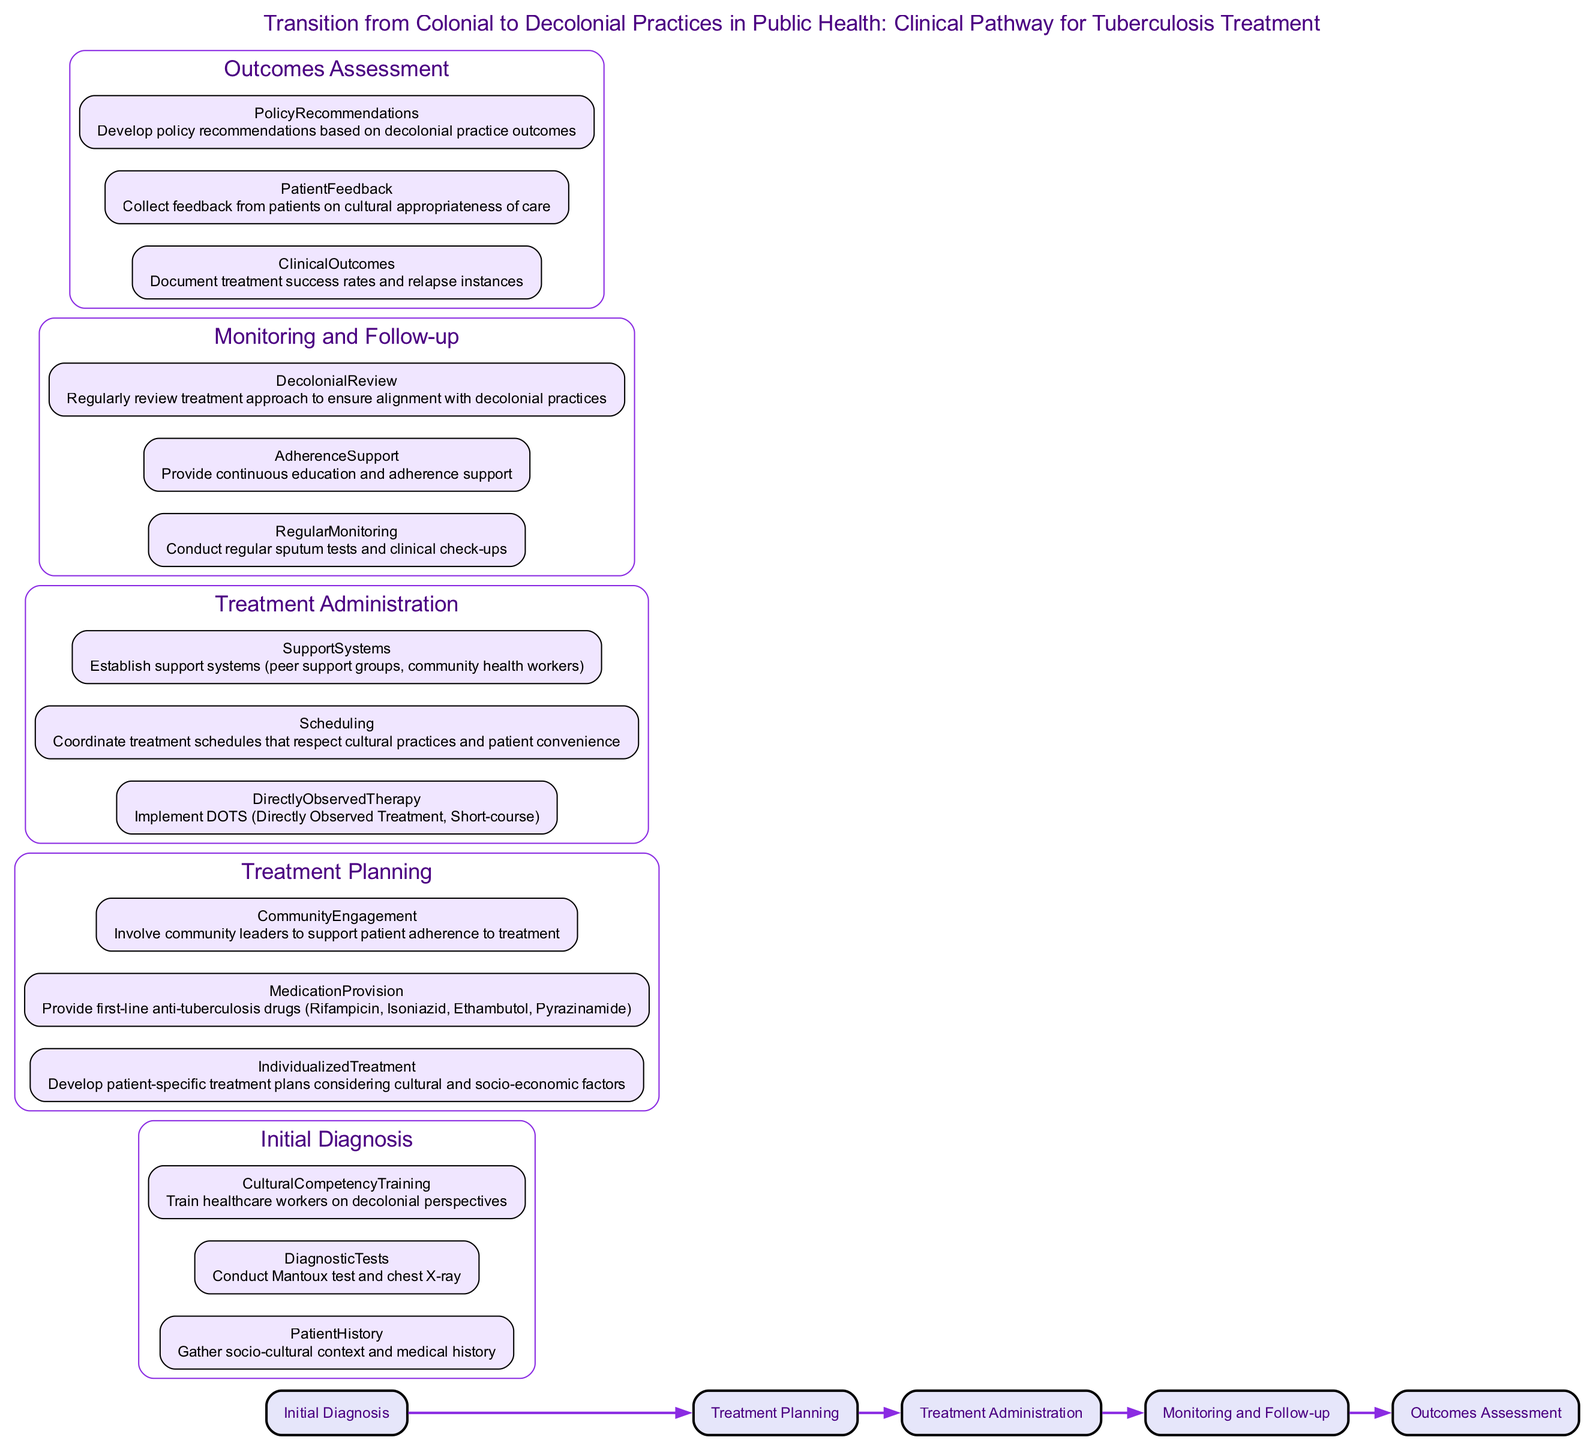What is the title of the clinical pathway? The title is displayed prominently at the top of the diagram. It explicitly states "Transition from Colonial to Decolonial Practices in Public Health: Clinical Pathway for Tuberculosis Treatment."
Answer: Transition from Colonial to Decolonial Practices in Public Health: Clinical Pathway for Tuberculosis Treatment How many stages are in the clinical pathway? Each stage is represented as a distinct node in the diagram. By counting the nodes, we find that there are five stages: Initial Diagnosis, Treatment Planning, Treatment Administration, Monitoring and Follow-up, and Outcomes Assessment.
Answer: 5 Which stage includes "Community Engagement"? The element "Community Engagement" is listed under the "Treatment Planning" stage, indicating that it is part of the planning phase for addressing tuberculosis treatment.
Answer: Treatment Planning What training is required in the Initial Diagnosis stage? The diagram specifies that "Cultural Competency Training" is a necessary component in the "Initial Diagnosis" stage, highlighting the focus on decolonial perspectives.
Answer: Cultural Competency Training In which stage is Directly Observed Therapy implemented? The "Directly Observed Therapy" is clearly stated as part of the "Treatment Administration" stage, suggesting an active approach to drug administration.
Answer: Treatment Administration What is a key aspect of the Monitoring and Follow-up stage? Regular monitoring is vital in the Monitoring and Follow-up stage, emphasizing the need for ongoing assessment of the patient's treatment progress.
Answer: Regular Monitoring What type of feedback is collected in the Outcomes Assessment stage? The Outcomes Assessment stage involves collecting "Patient Feedback" to understand the cultural appropriateness of care provided during treatment.
Answer: Patient Feedback What recommendation is developed based on the outcomes? The diagram indicates that "Policy Recommendations" are an important output of the Outcomes Assessment stage, reflecting the insights gained from the treatment process.
Answer: Policy Recommendations What element supports treatment adherence in the Treatment Administration stage? The establishment of "Support Systems" such as peer support groups and community health workers is a critical element aimed at enhancing patient adherence during the Treatment Administration stage.
Answer: Support Systems 